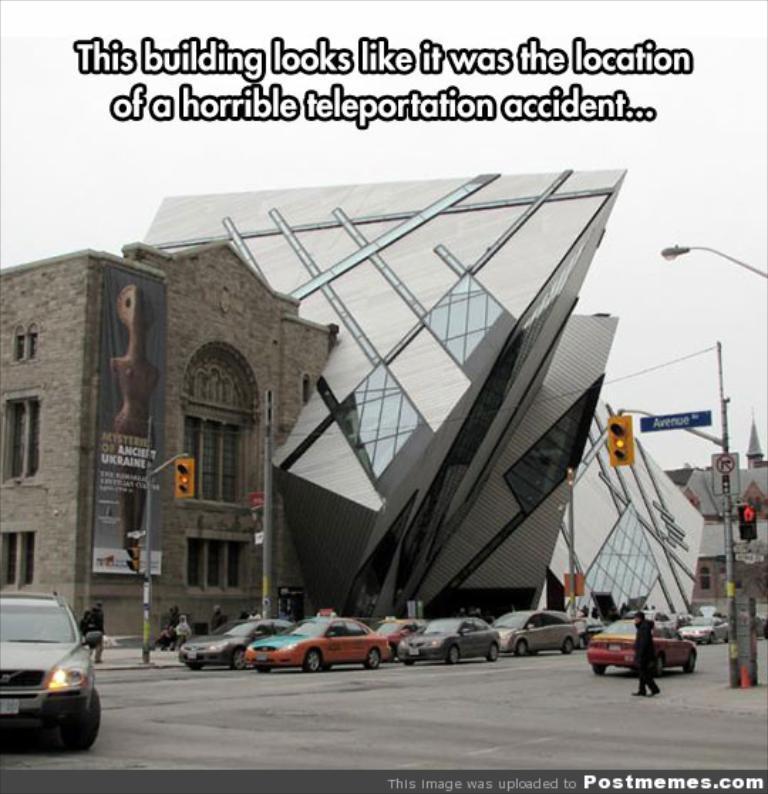Describe this image in one or two sentences. In the picture i can see some vehicles which are moving on road, there are some traffic signals and in the background of the picture there are some buildings. 